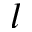<formula> <loc_0><loc_0><loc_500><loc_500>l</formula> 